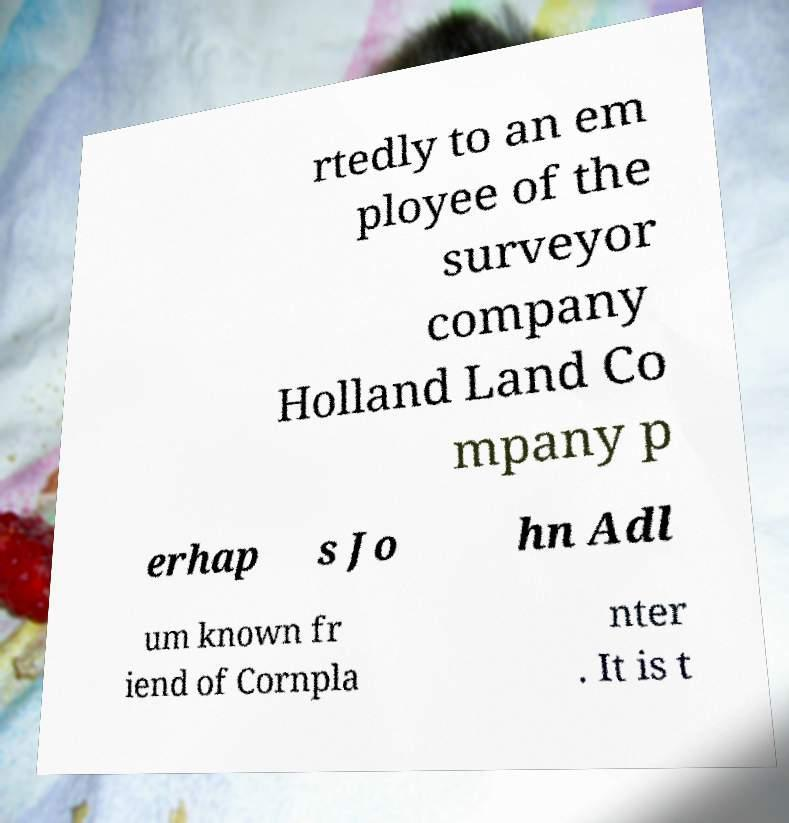Could you extract and type out the text from this image? rtedly to an em ployee of the surveyor company Holland Land Co mpany p erhap s Jo hn Adl um known fr iend of Cornpla nter . It is t 